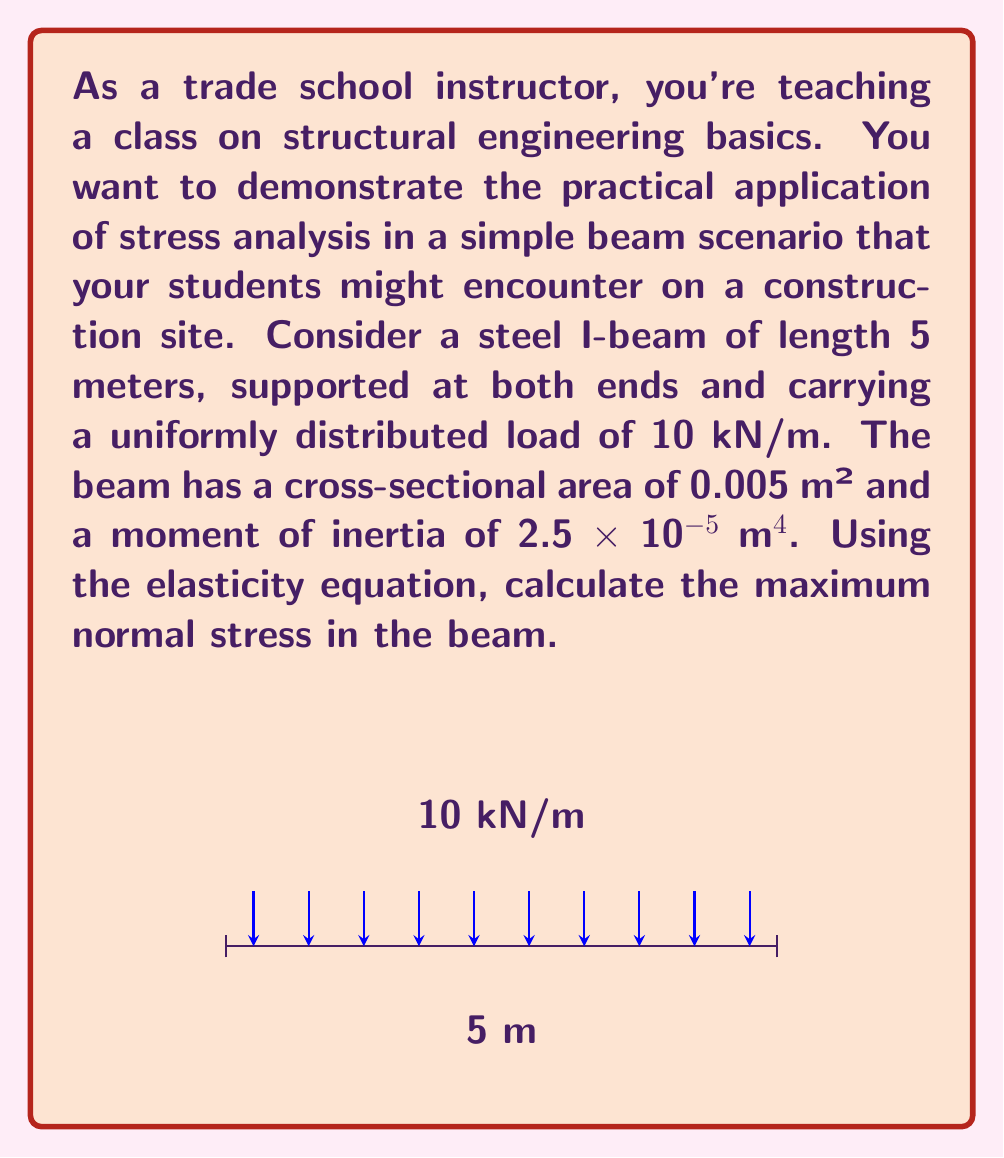Can you answer this question? Let's approach this step-by-step using the elasticity equation:

1) The maximum bending moment for a uniformly loaded beam occurs at the center and is given by:

   $$M_{max} = \frac{wL^2}{8}$$

   where $w$ is the distributed load and $L$ is the beam length.

2) Substituting the values:

   $$M_{max} = \frac{10 \text{ kN/m} \times (5 \text{ m})^2}{8} = 31.25 \text{ kN·m}$$

3) The elasticity equation for normal stress due to bending is:

   $$\sigma = \frac{My}{I}$$

   where $M$ is the bending moment, $y$ is the distance from the neutral axis to the extreme fiber, and $I$ is the moment of inertia.

4) For an I-beam, the maximum stress occurs at the extreme fibers. The distance $y$ from the neutral axis to the extreme fiber is half the beam depth. We can calculate this using the given cross-sectional area $A$ and moment of inertia $I$:

   $$y = \sqrt{\frac{I}{A}} = \sqrt{\frac{2.5 \times 10^{-5} \text{ m}^4}{0.005 \text{ m}^2}} = 0.0707 \text{ m}$$

5) Now we can calculate the maximum normal stress:

   $$\sigma_{max} = \frac{M_{max}y}{I} = \frac{31250 \text{ N·m} \times 0.0707 \text{ m}}{2.5 \times 10^{-5} \text{ m}^4} = 88.375 \times 10^6 \text{ Pa} = 88.375 \text{ MPa}$$
Answer: 88.375 MPa 